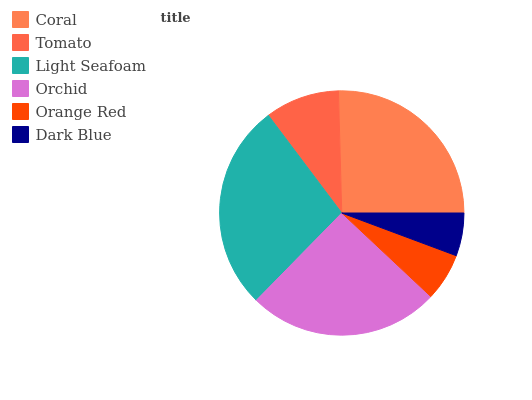Is Dark Blue the minimum?
Answer yes or no. Yes. Is Light Seafoam the maximum?
Answer yes or no. Yes. Is Tomato the minimum?
Answer yes or no. No. Is Tomato the maximum?
Answer yes or no. No. Is Coral greater than Tomato?
Answer yes or no. Yes. Is Tomato less than Coral?
Answer yes or no. Yes. Is Tomato greater than Coral?
Answer yes or no. No. Is Coral less than Tomato?
Answer yes or no. No. Is Orchid the high median?
Answer yes or no. Yes. Is Tomato the low median?
Answer yes or no. Yes. Is Light Seafoam the high median?
Answer yes or no. No. Is Orange Red the low median?
Answer yes or no. No. 